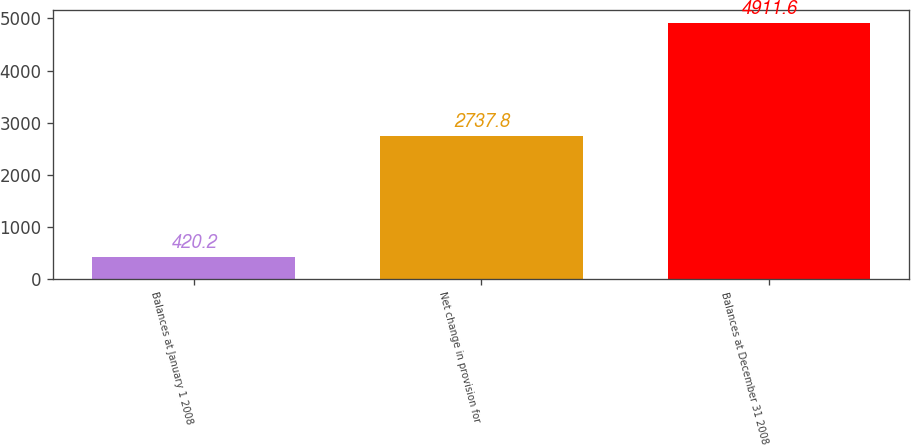Convert chart. <chart><loc_0><loc_0><loc_500><loc_500><bar_chart><fcel>Balances at January 1 2008<fcel>Net change in provision for<fcel>Balances at December 31 2008<nl><fcel>420.2<fcel>2737.8<fcel>4911.6<nl></chart> 